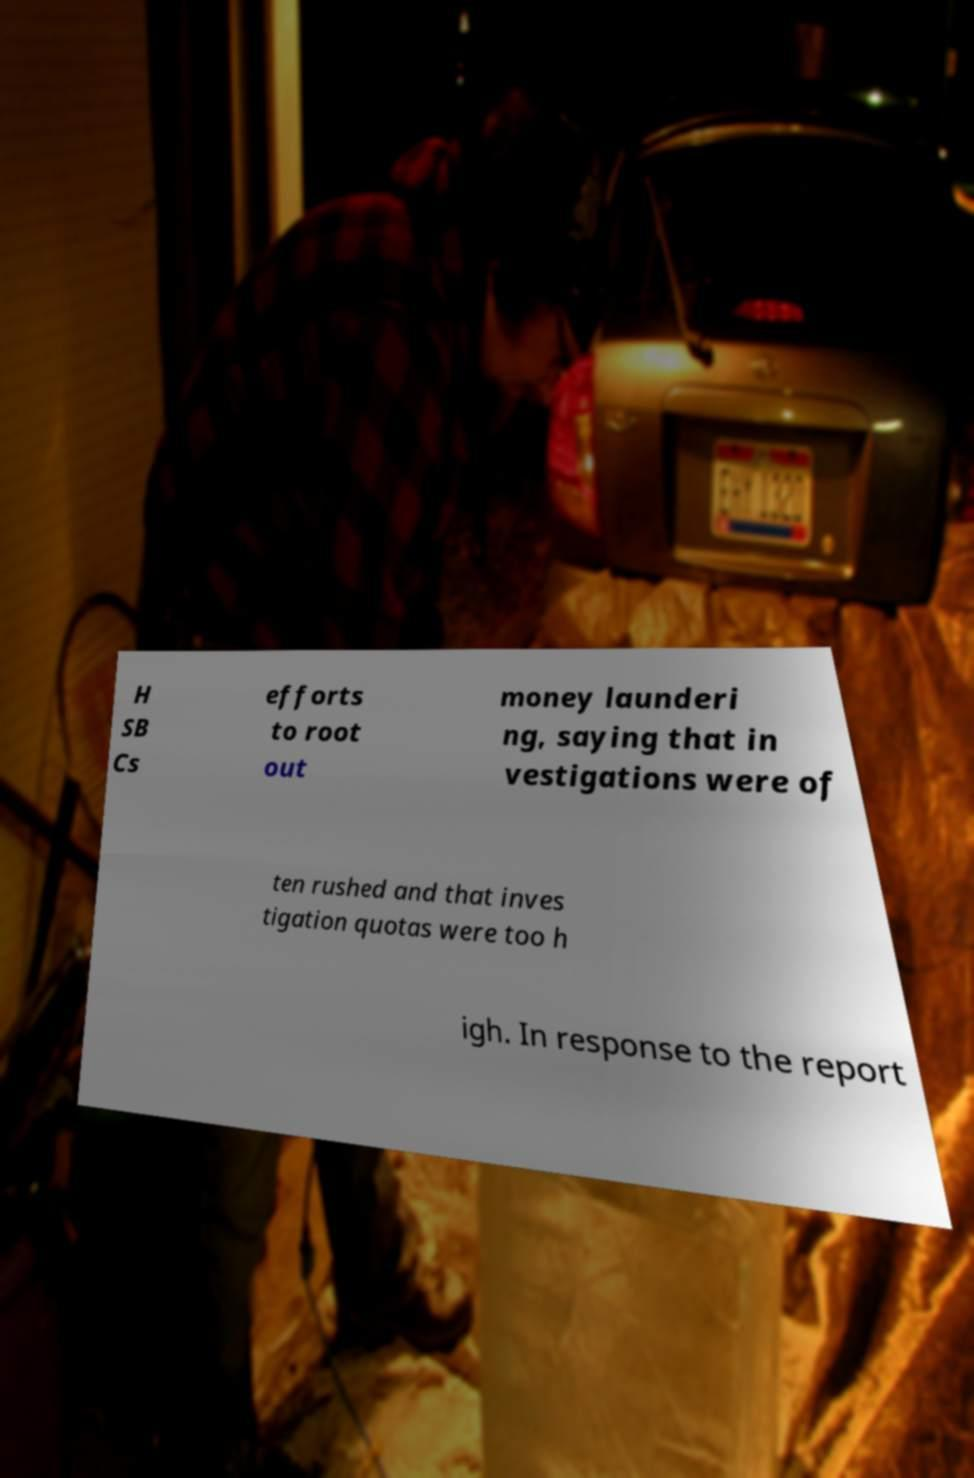I need the written content from this picture converted into text. Can you do that? H SB Cs efforts to root out money launderi ng, saying that in vestigations were of ten rushed and that inves tigation quotas were too h igh. In response to the report 